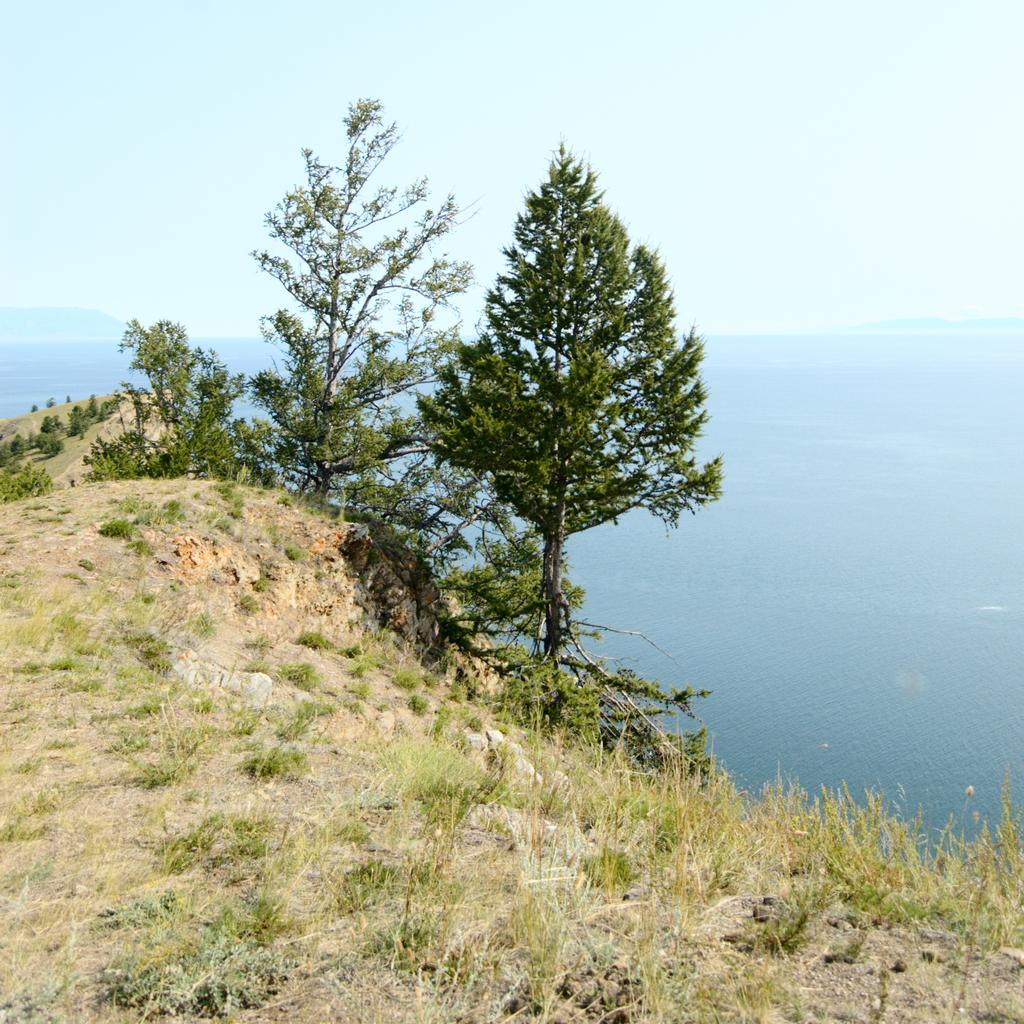What type of vegetation can be seen in the image? There is grass and trees in the image. What can be seen in the background of the image? Water and the sky are visible in the background of the image. Can you find the receipt for the toy in the image? There is no toy or receipt present in the image. 